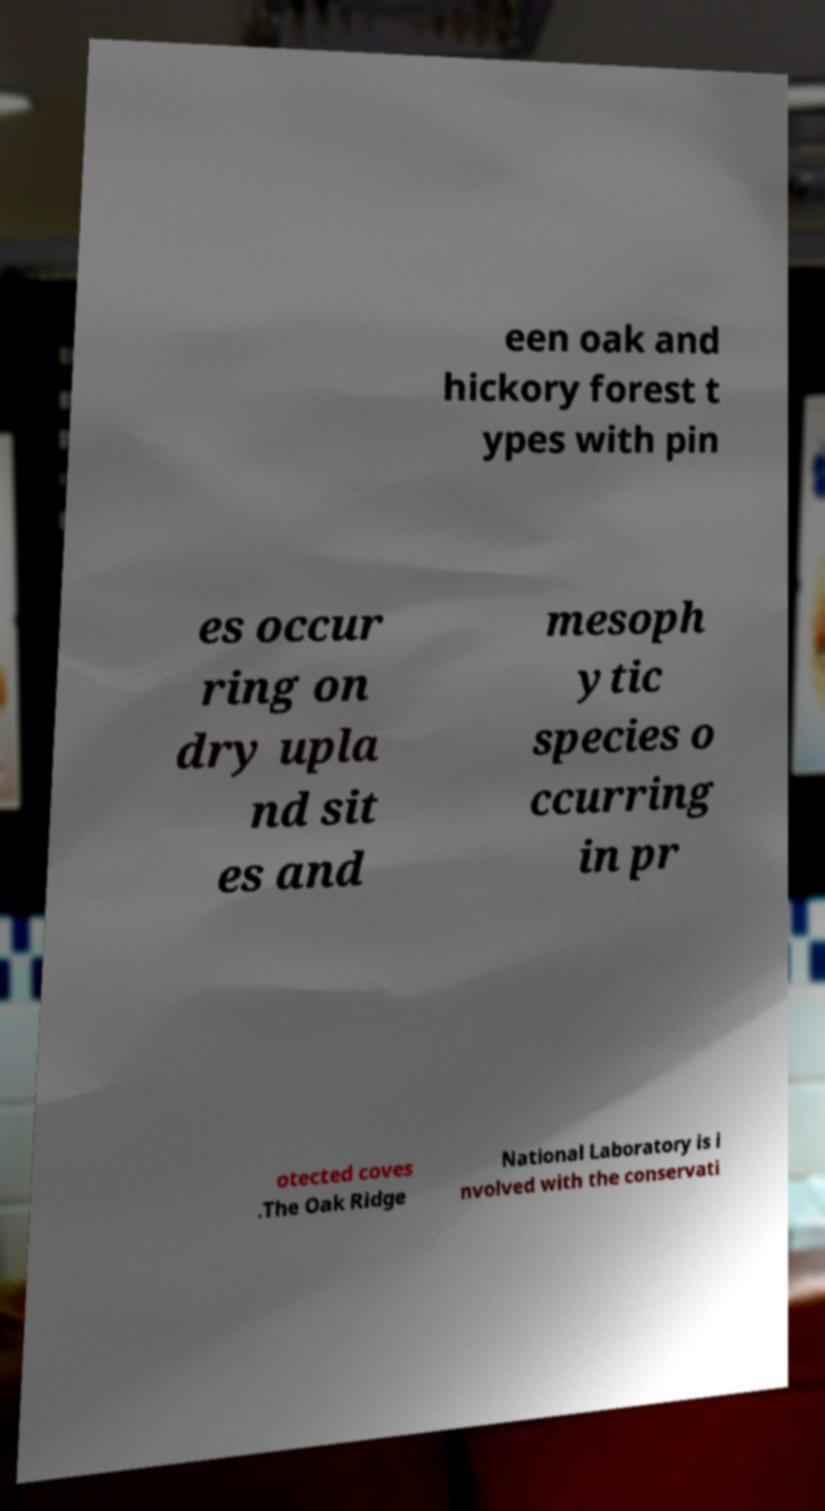Could you assist in decoding the text presented in this image and type it out clearly? een oak and hickory forest t ypes with pin es occur ring on dry upla nd sit es and mesoph ytic species o ccurring in pr otected coves .The Oak Ridge National Laboratory is i nvolved with the conservati 